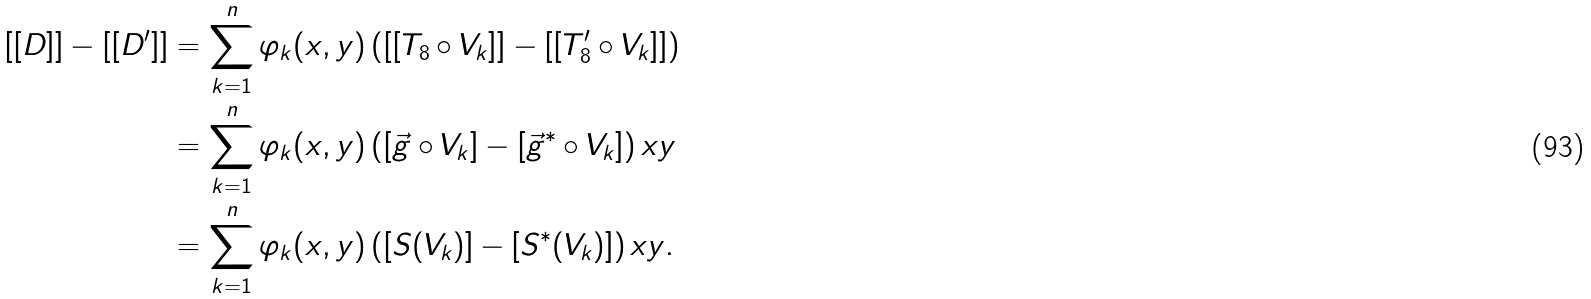<formula> <loc_0><loc_0><loc_500><loc_500>[ [ D ] ] - [ [ D ^ { \prime } ] ] & = \sum _ { k = 1 } ^ { n } \varphi _ { k } ( x , y ) \left ( [ [ T _ { 8 } \circ V _ { k } ] ] - [ [ T ^ { \prime } _ { 8 } \circ V _ { k } ] ] \right ) \\ & = \sum _ { k = 1 } ^ { n } \varphi _ { k } ( x , y ) \left ( [ \vec { g } \circ V _ { k } ] - [ \vec { g } ^ { * } \circ V _ { k } ] \right ) x y \\ & = \sum _ { k = 1 } ^ { n } \varphi _ { k } ( x , y ) \left ( [ S ( V _ { k } ) ] - [ S ^ { * } ( V _ { k } ) ] \right ) x y .</formula> 